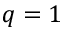<formula> <loc_0><loc_0><loc_500><loc_500>q = 1</formula> 